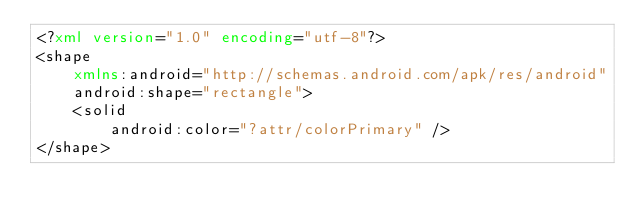Convert code to text. <code><loc_0><loc_0><loc_500><loc_500><_XML_><?xml version="1.0" encoding="utf-8"?>
<shape
    xmlns:android="http://schemas.android.com/apk/res/android"
    android:shape="rectangle">
    <solid
        android:color="?attr/colorPrimary" />
</shape></code> 